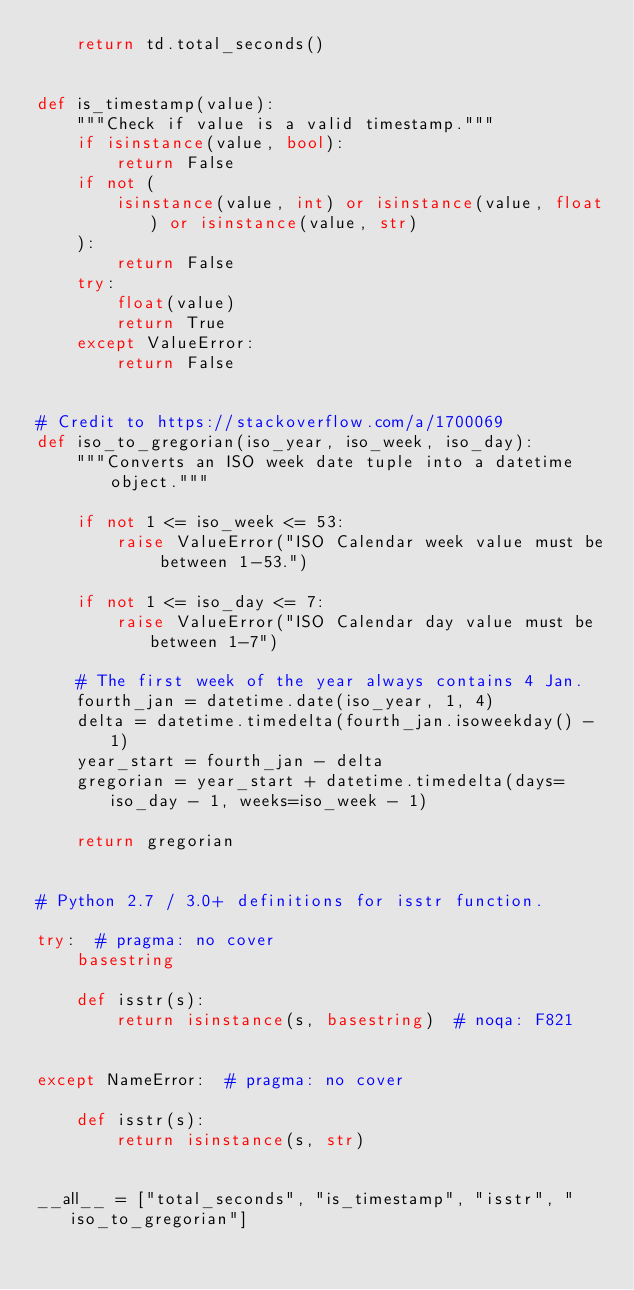<code> <loc_0><loc_0><loc_500><loc_500><_Python_>    return td.total_seconds()


def is_timestamp(value):
    """Check if value is a valid timestamp."""
    if isinstance(value, bool):
        return False
    if not (
        isinstance(value, int) or isinstance(value, float) or isinstance(value, str)
    ):
        return False
    try:
        float(value)
        return True
    except ValueError:
        return False


# Credit to https://stackoverflow.com/a/1700069
def iso_to_gregorian(iso_year, iso_week, iso_day):
    """Converts an ISO week date tuple into a datetime object."""

    if not 1 <= iso_week <= 53:
        raise ValueError("ISO Calendar week value must be between 1-53.")

    if not 1 <= iso_day <= 7:
        raise ValueError("ISO Calendar day value must be between 1-7")

    # The first week of the year always contains 4 Jan.
    fourth_jan = datetime.date(iso_year, 1, 4)
    delta = datetime.timedelta(fourth_jan.isoweekday() - 1)
    year_start = fourth_jan - delta
    gregorian = year_start + datetime.timedelta(days=iso_day - 1, weeks=iso_week - 1)

    return gregorian


# Python 2.7 / 3.0+ definitions for isstr function.

try:  # pragma: no cover
    basestring

    def isstr(s):
        return isinstance(s, basestring)  # noqa: F821


except NameError:  # pragma: no cover

    def isstr(s):
        return isinstance(s, str)


__all__ = ["total_seconds", "is_timestamp", "isstr", "iso_to_gregorian"]
</code> 